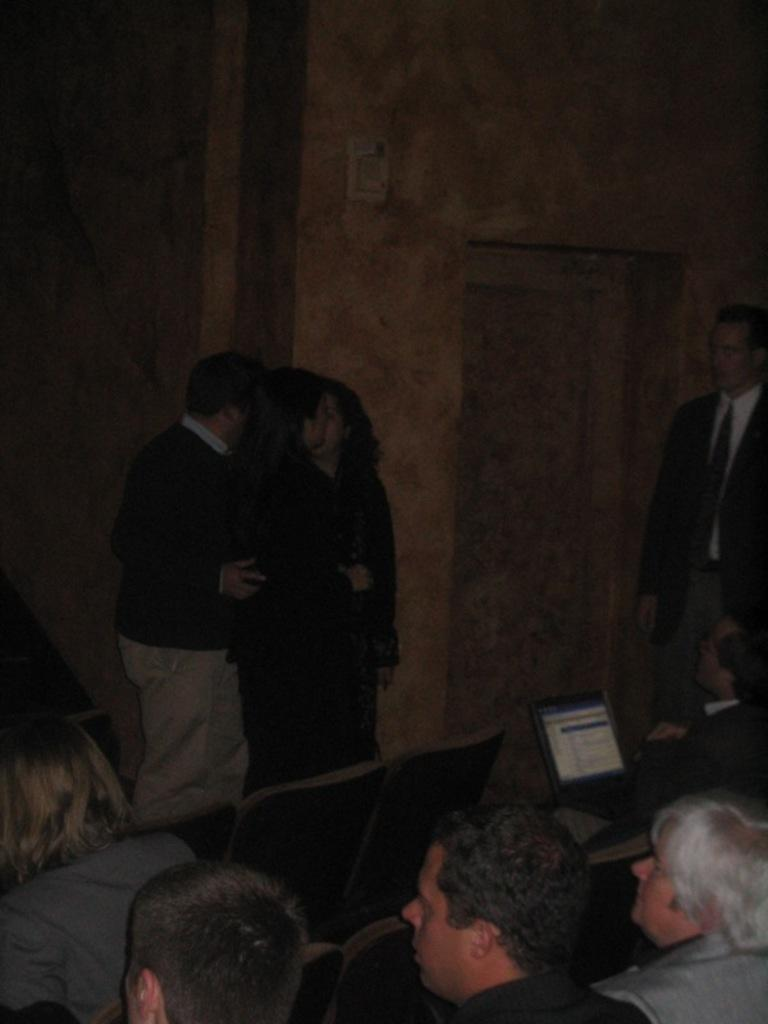How many people are in the image? There is a group of people in the image. What are some of the people in the image doing? Some people are sitting on chairs, and three people are standing. What electronic device can be seen in the image? There is a laptop in the image. What is visible in the background of the image? There is a wall in the background of the image. What type of elbow can be seen on the laptop in the image? There is no elbow present on the laptop in the image; it is an electronic device without any body parts. 